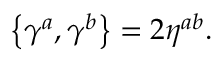<formula> <loc_0><loc_0><loc_500><loc_500>\left \{ \gamma ^ { a } , \gamma ^ { b } \right \} = 2 \eta ^ { a b } .</formula> 